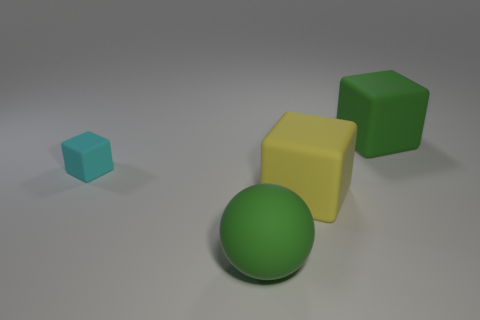Add 3 green cubes. How many objects exist? 7 Subtract all blocks. How many objects are left? 1 Subtract 0 yellow cylinders. How many objects are left? 4 Subtract all big green cubes. Subtract all small cyan matte objects. How many objects are left? 2 Add 4 large yellow blocks. How many large yellow blocks are left? 5 Add 3 cyan cubes. How many cyan cubes exist? 4 